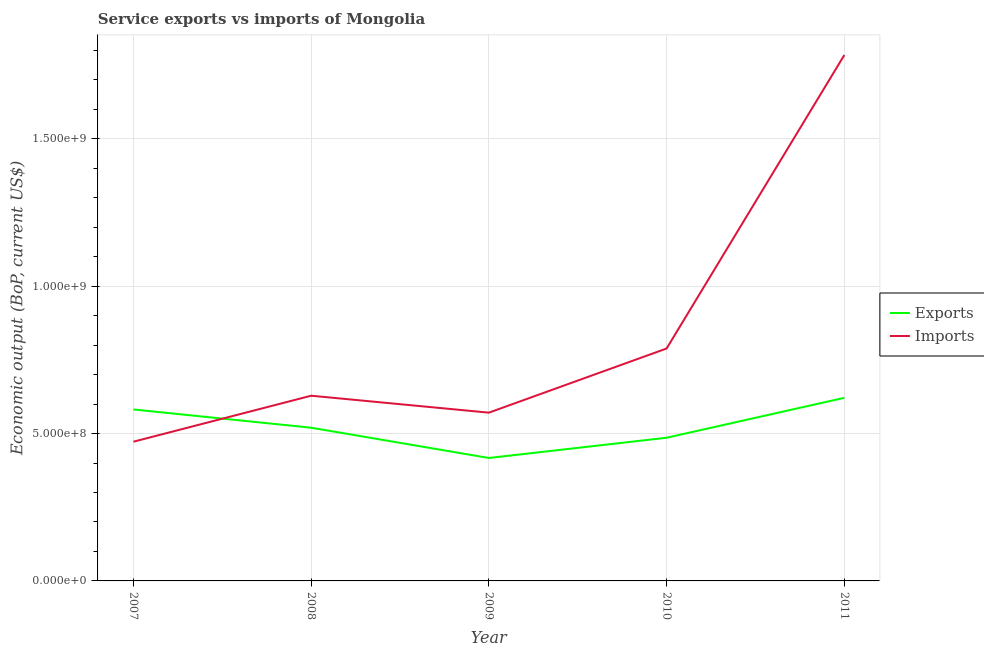Does the line corresponding to amount of service imports intersect with the line corresponding to amount of service exports?
Your response must be concise. Yes. Is the number of lines equal to the number of legend labels?
Keep it short and to the point. Yes. What is the amount of service exports in 2008?
Make the answer very short. 5.20e+08. Across all years, what is the maximum amount of service exports?
Your response must be concise. 6.21e+08. Across all years, what is the minimum amount of service exports?
Keep it short and to the point. 4.17e+08. In which year was the amount of service imports maximum?
Your answer should be very brief. 2011. What is the total amount of service exports in the graph?
Your response must be concise. 2.63e+09. What is the difference between the amount of service imports in 2008 and that in 2009?
Your answer should be very brief. 5.75e+07. What is the difference between the amount of service exports in 2010 and the amount of service imports in 2009?
Give a very brief answer. -8.51e+07. What is the average amount of service exports per year?
Give a very brief answer. 5.25e+08. In the year 2010, what is the difference between the amount of service exports and amount of service imports?
Offer a very short reply. -3.03e+08. What is the ratio of the amount of service imports in 2007 to that in 2009?
Your response must be concise. 0.83. Is the amount of service exports in 2008 less than that in 2011?
Offer a terse response. Yes. Is the difference between the amount of service exports in 2007 and 2009 greater than the difference between the amount of service imports in 2007 and 2009?
Your response must be concise. Yes. What is the difference between the highest and the second highest amount of service imports?
Your answer should be very brief. 9.96e+08. What is the difference between the highest and the lowest amount of service exports?
Your answer should be very brief. 2.04e+08. Does the amount of service imports monotonically increase over the years?
Provide a short and direct response. No. Is the amount of service exports strictly greater than the amount of service imports over the years?
Give a very brief answer. No. Is the amount of service imports strictly less than the amount of service exports over the years?
Ensure brevity in your answer.  No. How many lines are there?
Offer a terse response. 2. How many years are there in the graph?
Your answer should be compact. 5. Does the graph contain grids?
Give a very brief answer. Yes. How many legend labels are there?
Your answer should be compact. 2. What is the title of the graph?
Offer a very short reply. Service exports vs imports of Mongolia. Does "Ages 15-24" appear as one of the legend labels in the graph?
Ensure brevity in your answer.  No. What is the label or title of the X-axis?
Your answer should be compact. Year. What is the label or title of the Y-axis?
Keep it short and to the point. Economic output (BoP, current US$). What is the Economic output (BoP, current US$) in Exports in 2007?
Your answer should be compact. 5.82e+08. What is the Economic output (BoP, current US$) of Imports in 2007?
Provide a short and direct response. 4.72e+08. What is the Economic output (BoP, current US$) in Exports in 2008?
Your answer should be very brief. 5.20e+08. What is the Economic output (BoP, current US$) of Imports in 2008?
Keep it short and to the point. 6.28e+08. What is the Economic output (BoP, current US$) of Exports in 2009?
Provide a succinct answer. 4.17e+08. What is the Economic output (BoP, current US$) in Imports in 2009?
Keep it short and to the point. 5.71e+08. What is the Economic output (BoP, current US$) in Exports in 2010?
Keep it short and to the point. 4.86e+08. What is the Economic output (BoP, current US$) of Imports in 2010?
Your answer should be very brief. 7.89e+08. What is the Economic output (BoP, current US$) of Exports in 2011?
Keep it short and to the point. 6.21e+08. What is the Economic output (BoP, current US$) of Imports in 2011?
Keep it short and to the point. 1.78e+09. Across all years, what is the maximum Economic output (BoP, current US$) in Exports?
Ensure brevity in your answer.  6.21e+08. Across all years, what is the maximum Economic output (BoP, current US$) of Imports?
Offer a very short reply. 1.78e+09. Across all years, what is the minimum Economic output (BoP, current US$) in Exports?
Keep it short and to the point. 4.17e+08. Across all years, what is the minimum Economic output (BoP, current US$) of Imports?
Your response must be concise. 4.72e+08. What is the total Economic output (BoP, current US$) of Exports in the graph?
Your answer should be very brief. 2.63e+09. What is the total Economic output (BoP, current US$) in Imports in the graph?
Provide a short and direct response. 4.25e+09. What is the difference between the Economic output (BoP, current US$) of Exports in 2007 and that in 2008?
Provide a succinct answer. 6.19e+07. What is the difference between the Economic output (BoP, current US$) in Imports in 2007 and that in 2008?
Your answer should be very brief. -1.56e+08. What is the difference between the Economic output (BoP, current US$) of Exports in 2007 and that in 2009?
Provide a succinct answer. 1.65e+08. What is the difference between the Economic output (BoP, current US$) of Imports in 2007 and that in 2009?
Make the answer very short. -9.86e+07. What is the difference between the Economic output (BoP, current US$) in Exports in 2007 and that in 2010?
Offer a terse response. 9.60e+07. What is the difference between the Economic output (BoP, current US$) of Imports in 2007 and that in 2010?
Offer a terse response. -3.16e+08. What is the difference between the Economic output (BoP, current US$) in Exports in 2007 and that in 2011?
Ensure brevity in your answer.  -3.95e+07. What is the difference between the Economic output (BoP, current US$) in Imports in 2007 and that in 2011?
Provide a succinct answer. -1.31e+09. What is the difference between the Economic output (BoP, current US$) in Exports in 2008 and that in 2009?
Your response must be concise. 1.03e+08. What is the difference between the Economic output (BoP, current US$) in Imports in 2008 and that in 2009?
Ensure brevity in your answer.  5.75e+07. What is the difference between the Economic output (BoP, current US$) in Exports in 2008 and that in 2010?
Your answer should be compact. 3.40e+07. What is the difference between the Economic output (BoP, current US$) in Imports in 2008 and that in 2010?
Your answer should be very brief. -1.60e+08. What is the difference between the Economic output (BoP, current US$) in Exports in 2008 and that in 2011?
Your response must be concise. -1.01e+08. What is the difference between the Economic output (BoP, current US$) of Imports in 2008 and that in 2011?
Make the answer very short. -1.16e+09. What is the difference between the Economic output (BoP, current US$) of Exports in 2009 and that in 2010?
Ensure brevity in your answer.  -6.87e+07. What is the difference between the Economic output (BoP, current US$) in Imports in 2009 and that in 2010?
Ensure brevity in your answer.  -2.18e+08. What is the difference between the Economic output (BoP, current US$) of Exports in 2009 and that in 2011?
Offer a very short reply. -2.04e+08. What is the difference between the Economic output (BoP, current US$) of Imports in 2009 and that in 2011?
Give a very brief answer. -1.21e+09. What is the difference between the Economic output (BoP, current US$) in Exports in 2010 and that in 2011?
Make the answer very short. -1.35e+08. What is the difference between the Economic output (BoP, current US$) of Imports in 2010 and that in 2011?
Your answer should be very brief. -9.96e+08. What is the difference between the Economic output (BoP, current US$) of Exports in 2007 and the Economic output (BoP, current US$) of Imports in 2008?
Provide a succinct answer. -4.67e+07. What is the difference between the Economic output (BoP, current US$) in Exports in 2007 and the Economic output (BoP, current US$) in Imports in 2009?
Your answer should be compact. 1.08e+07. What is the difference between the Economic output (BoP, current US$) of Exports in 2007 and the Economic output (BoP, current US$) of Imports in 2010?
Keep it short and to the point. -2.07e+08. What is the difference between the Economic output (BoP, current US$) in Exports in 2007 and the Economic output (BoP, current US$) in Imports in 2011?
Give a very brief answer. -1.20e+09. What is the difference between the Economic output (BoP, current US$) of Exports in 2008 and the Economic output (BoP, current US$) of Imports in 2009?
Keep it short and to the point. -5.11e+07. What is the difference between the Economic output (BoP, current US$) of Exports in 2008 and the Economic output (BoP, current US$) of Imports in 2010?
Your answer should be compact. -2.69e+08. What is the difference between the Economic output (BoP, current US$) in Exports in 2008 and the Economic output (BoP, current US$) in Imports in 2011?
Your response must be concise. -1.26e+09. What is the difference between the Economic output (BoP, current US$) of Exports in 2009 and the Economic output (BoP, current US$) of Imports in 2010?
Ensure brevity in your answer.  -3.72e+08. What is the difference between the Economic output (BoP, current US$) of Exports in 2009 and the Economic output (BoP, current US$) of Imports in 2011?
Offer a terse response. -1.37e+09. What is the difference between the Economic output (BoP, current US$) of Exports in 2010 and the Economic output (BoP, current US$) of Imports in 2011?
Make the answer very short. -1.30e+09. What is the average Economic output (BoP, current US$) of Exports per year?
Offer a terse response. 5.25e+08. What is the average Economic output (BoP, current US$) in Imports per year?
Give a very brief answer. 8.49e+08. In the year 2007, what is the difference between the Economic output (BoP, current US$) in Exports and Economic output (BoP, current US$) in Imports?
Give a very brief answer. 1.09e+08. In the year 2008, what is the difference between the Economic output (BoP, current US$) of Exports and Economic output (BoP, current US$) of Imports?
Provide a succinct answer. -1.09e+08. In the year 2009, what is the difference between the Economic output (BoP, current US$) in Exports and Economic output (BoP, current US$) in Imports?
Ensure brevity in your answer.  -1.54e+08. In the year 2010, what is the difference between the Economic output (BoP, current US$) in Exports and Economic output (BoP, current US$) in Imports?
Your response must be concise. -3.03e+08. In the year 2011, what is the difference between the Economic output (BoP, current US$) of Exports and Economic output (BoP, current US$) of Imports?
Keep it short and to the point. -1.16e+09. What is the ratio of the Economic output (BoP, current US$) in Exports in 2007 to that in 2008?
Offer a terse response. 1.12. What is the ratio of the Economic output (BoP, current US$) of Imports in 2007 to that in 2008?
Provide a succinct answer. 0.75. What is the ratio of the Economic output (BoP, current US$) in Exports in 2007 to that in 2009?
Your response must be concise. 1.39. What is the ratio of the Economic output (BoP, current US$) of Imports in 2007 to that in 2009?
Your answer should be compact. 0.83. What is the ratio of the Economic output (BoP, current US$) in Exports in 2007 to that in 2010?
Give a very brief answer. 1.2. What is the ratio of the Economic output (BoP, current US$) of Imports in 2007 to that in 2010?
Your answer should be very brief. 0.6. What is the ratio of the Economic output (BoP, current US$) in Exports in 2007 to that in 2011?
Your answer should be compact. 0.94. What is the ratio of the Economic output (BoP, current US$) of Imports in 2007 to that in 2011?
Offer a very short reply. 0.26. What is the ratio of the Economic output (BoP, current US$) of Exports in 2008 to that in 2009?
Your response must be concise. 1.25. What is the ratio of the Economic output (BoP, current US$) of Imports in 2008 to that in 2009?
Make the answer very short. 1.1. What is the ratio of the Economic output (BoP, current US$) in Exports in 2008 to that in 2010?
Provide a succinct answer. 1.07. What is the ratio of the Economic output (BoP, current US$) in Imports in 2008 to that in 2010?
Give a very brief answer. 0.8. What is the ratio of the Economic output (BoP, current US$) in Exports in 2008 to that in 2011?
Provide a succinct answer. 0.84. What is the ratio of the Economic output (BoP, current US$) of Imports in 2008 to that in 2011?
Your response must be concise. 0.35. What is the ratio of the Economic output (BoP, current US$) in Exports in 2009 to that in 2010?
Provide a short and direct response. 0.86. What is the ratio of the Economic output (BoP, current US$) in Imports in 2009 to that in 2010?
Offer a very short reply. 0.72. What is the ratio of the Economic output (BoP, current US$) of Exports in 2009 to that in 2011?
Your answer should be very brief. 0.67. What is the ratio of the Economic output (BoP, current US$) in Imports in 2009 to that in 2011?
Provide a succinct answer. 0.32. What is the ratio of the Economic output (BoP, current US$) in Exports in 2010 to that in 2011?
Ensure brevity in your answer.  0.78. What is the ratio of the Economic output (BoP, current US$) of Imports in 2010 to that in 2011?
Your answer should be very brief. 0.44. What is the difference between the highest and the second highest Economic output (BoP, current US$) in Exports?
Your answer should be very brief. 3.95e+07. What is the difference between the highest and the second highest Economic output (BoP, current US$) in Imports?
Offer a very short reply. 9.96e+08. What is the difference between the highest and the lowest Economic output (BoP, current US$) in Exports?
Your response must be concise. 2.04e+08. What is the difference between the highest and the lowest Economic output (BoP, current US$) of Imports?
Your answer should be compact. 1.31e+09. 